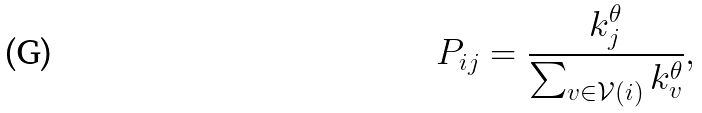Convert formula to latex. <formula><loc_0><loc_0><loc_500><loc_500>P _ { i j } = \frac { k _ { j } ^ { \theta } } { \sum _ { v \in \mathcal { V } ( i ) } k _ { v } ^ { \theta } } ,</formula> 